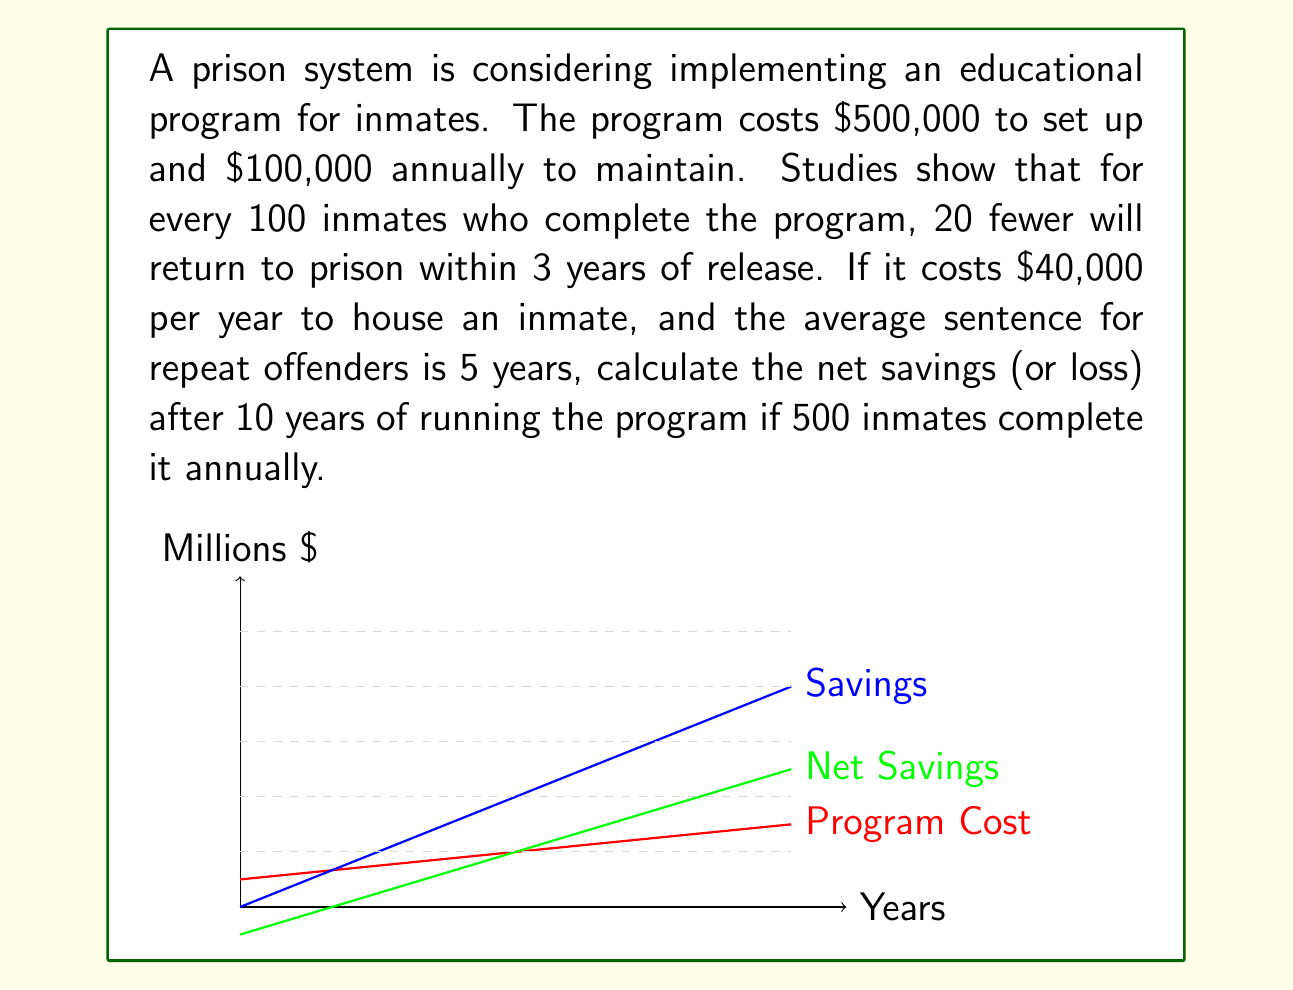Provide a solution to this math problem. Let's break this down step-by-step:

1) First, let's calculate the total cost of the program over 10 years:
   Setup cost: $500,000
   Annual maintenance: $100,000 × 10 years = $1,000,000
   Total cost: $500,000 + $1,000,000 = $1,500,000

2) Now, let's calculate how many inmates won't return to prison:
   500 inmates complete the program annually
   20% of 500 = 100 inmates per year don't return
   Over 10 years: 100 × 10 = 1,000 inmates don't return

3) Calculate the savings from inmates not returning:
   Cost per inmate per year: $40,000
   Average sentence: 5 years
   Savings per inmate: $40,000 × 5 = $200,000
   Total savings: $200,000 × 1,000 = $200,000,000

4) Calculate net savings:
   Net savings = Total savings - Total cost
   $$ \text{Net savings} = $200,000,000 - $1,500,000 = $198,500,000 $$

Therefore, after 10 years, the program will result in a net savings of $198,500,000.
Answer: $198,500,000 